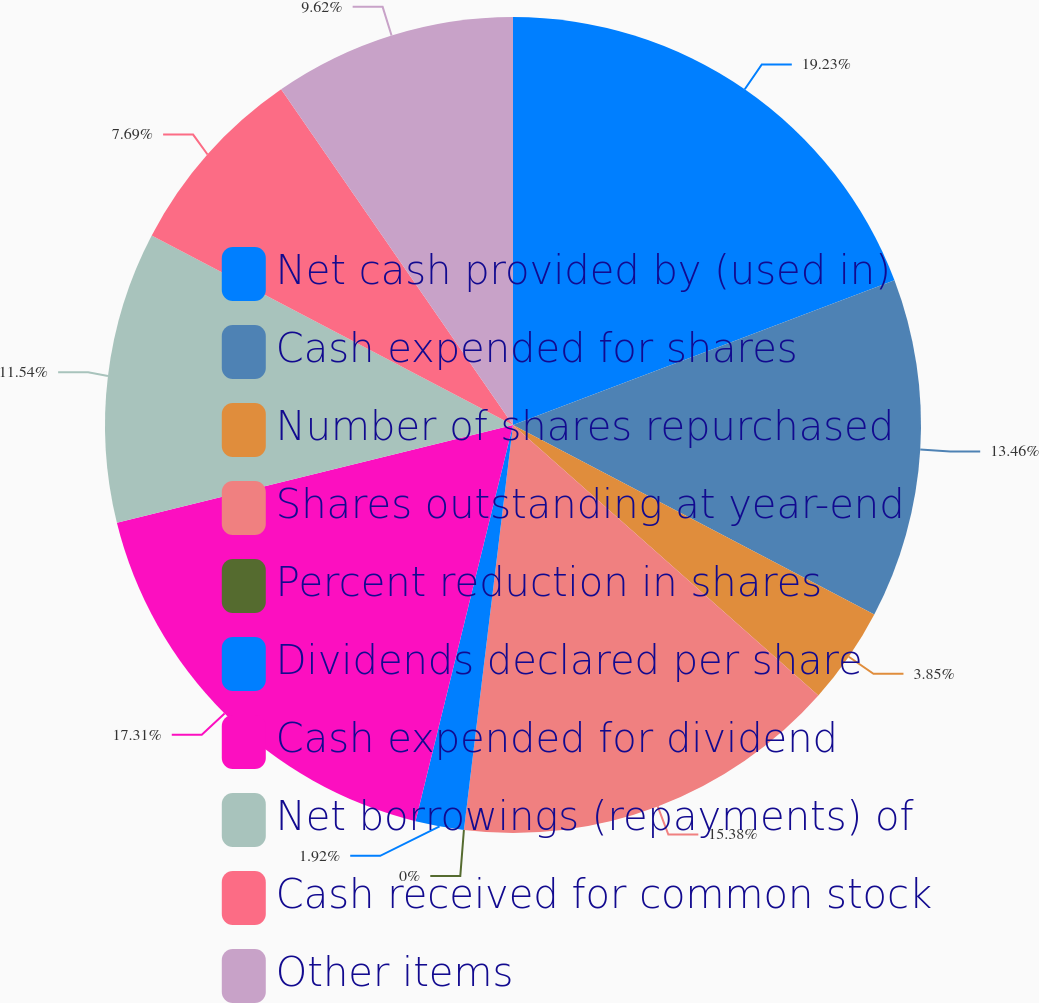Convert chart to OTSL. <chart><loc_0><loc_0><loc_500><loc_500><pie_chart><fcel>Net cash provided by (used in)<fcel>Cash expended for shares<fcel>Number of shares repurchased<fcel>Shares outstanding at year-end<fcel>Percent reduction in shares<fcel>Dividends declared per share<fcel>Cash expended for dividend<fcel>Net borrowings (repayments) of<fcel>Cash received for common stock<fcel>Other items<nl><fcel>19.23%<fcel>13.46%<fcel>3.85%<fcel>15.38%<fcel>0.0%<fcel>1.92%<fcel>17.31%<fcel>11.54%<fcel>7.69%<fcel>9.62%<nl></chart> 